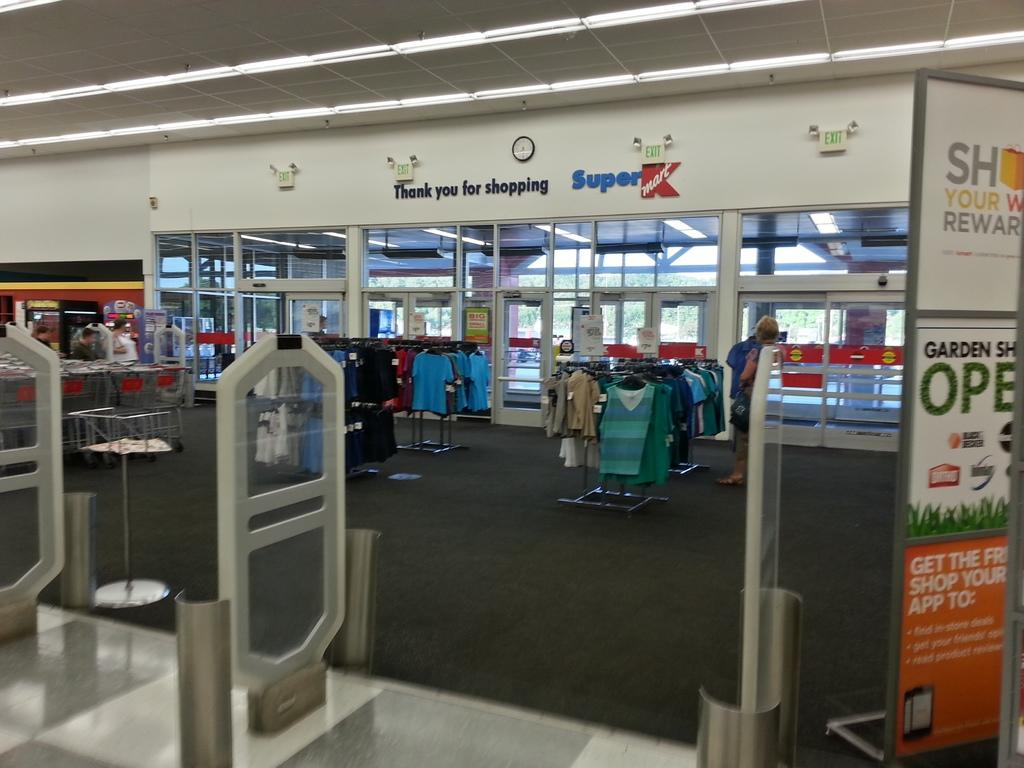<image>
Summarize the visual content of the image. Thank you for shopping and Super Kmart can be seen in this photo. 